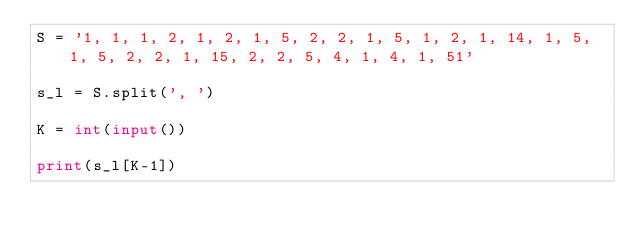<code> <loc_0><loc_0><loc_500><loc_500><_Python_>S = '1, 1, 1, 2, 1, 2, 1, 5, 2, 2, 1, 5, 1, 2, 1, 14, 1, 5, 1, 5, 2, 2, 1, 15, 2, 2, 5, 4, 1, 4, 1, 51'

s_l = S.split(', ')

K = int(input())

print(s_l[K-1])
</code> 